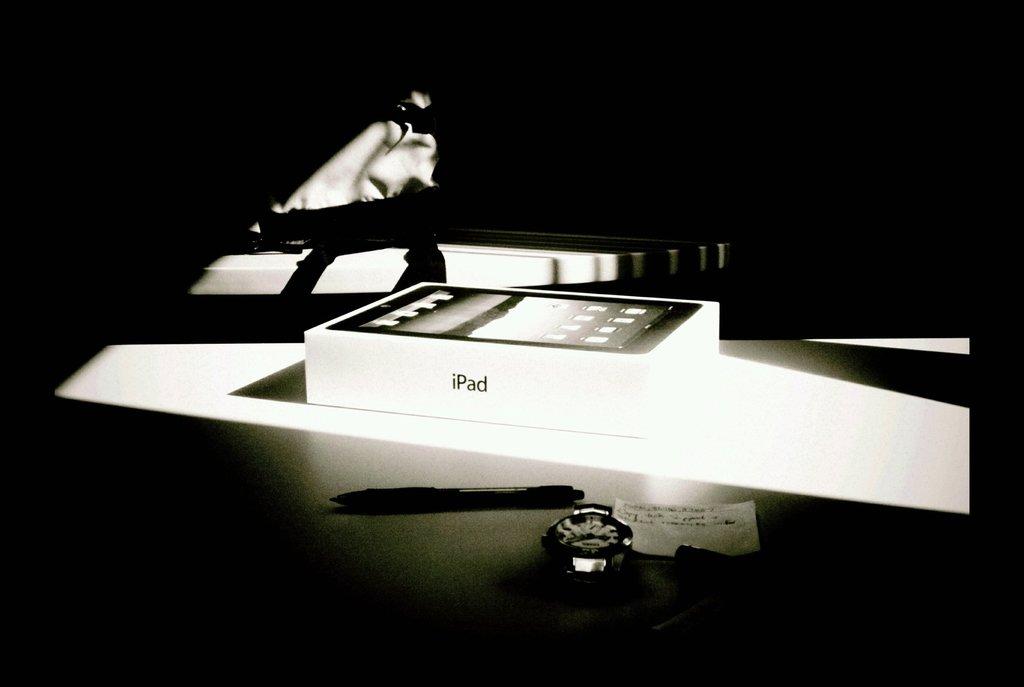Is this an ad for the ipad?
Your answer should be compact. Yes. What brand name is on the side of the box?
Your answer should be compact. Ipad. 